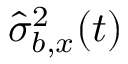Convert formula to latex. <formula><loc_0><loc_0><loc_500><loc_500>{ \hat { \sigma } _ { b , x } ^ { 2 } ( t ) }</formula> 